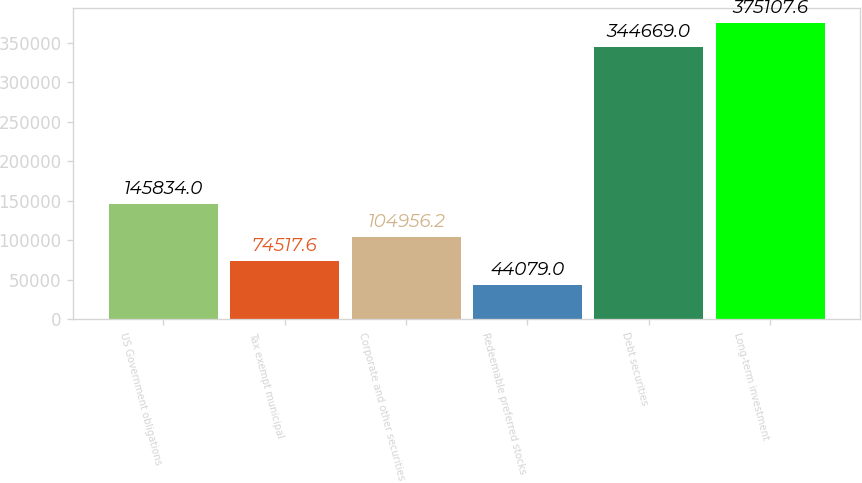Convert chart to OTSL. <chart><loc_0><loc_0><loc_500><loc_500><bar_chart><fcel>US Government obligations<fcel>Tax exempt municipal<fcel>Corporate and other securities<fcel>Redeemable preferred stocks<fcel>Debt securities<fcel>Long-term investment<nl><fcel>145834<fcel>74517.6<fcel>104956<fcel>44079<fcel>344669<fcel>375108<nl></chart> 